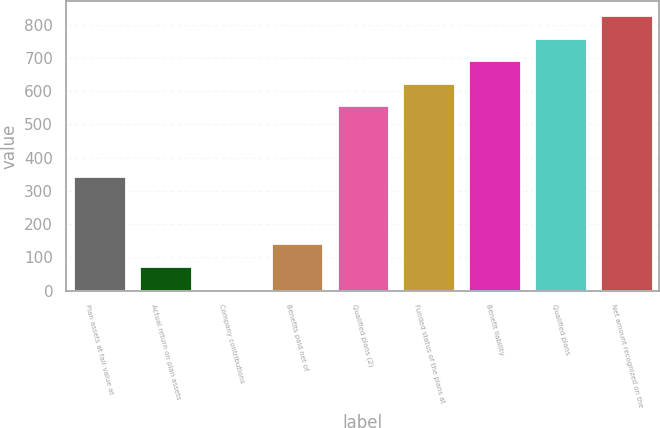Convert chart to OTSL. <chart><loc_0><loc_0><loc_500><loc_500><bar_chart><fcel>Plan assets at fair value at<fcel>Actual return on plan assets<fcel>Company contributions<fcel>Benefits paid net of<fcel>Qualified plans (2)<fcel>Funded status of the plans at<fcel>Benefit liability<fcel>Qualified plans<fcel>Net amount recognized on the<nl><fcel>346<fcel>74<fcel>6<fcel>142<fcel>557<fcel>625<fcel>693<fcel>761<fcel>829<nl></chart> 